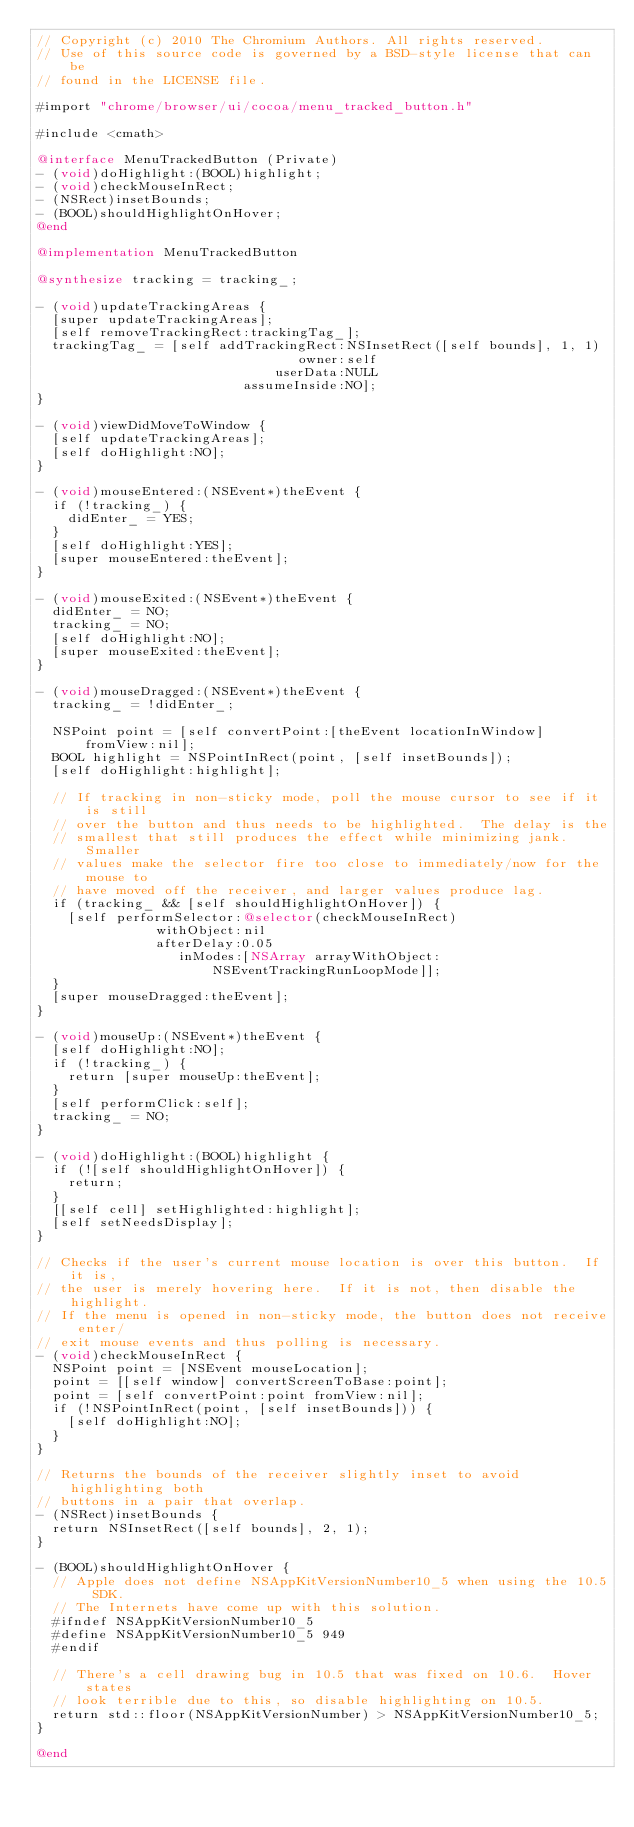<code> <loc_0><loc_0><loc_500><loc_500><_ObjectiveC_>// Copyright (c) 2010 The Chromium Authors. All rights reserved.
// Use of this source code is governed by a BSD-style license that can be
// found in the LICENSE file.

#import "chrome/browser/ui/cocoa/menu_tracked_button.h"

#include <cmath>

@interface MenuTrackedButton (Private)
- (void)doHighlight:(BOOL)highlight;
- (void)checkMouseInRect;
- (NSRect)insetBounds;
- (BOOL)shouldHighlightOnHover;
@end

@implementation MenuTrackedButton

@synthesize tracking = tracking_;

- (void)updateTrackingAreas {
  [super updateTrackingAreas];
  [self removeTrackingRect:trackingTag_];
  trackingTag_ = [self addTrackingRect:NSInsetRect([self bounds], 1, 1)
                                 owner:self
                              userData:NULL
                          assumeInside:NO];
}

- (void)viewDidMoveToWindow {
  [self updateTrackingAreas];
  [self doHighlight:NO];
}

- (void)mouseEntered:(NSEvent*)theEvent {
  if (!tracking_) {
    didEnter_ = YES;
  }
  [self doHighlight:YES];
  [super mouseEntered:theEvent];
}

- (void)mouseExited:(NSEvent*)theEvent {
  didEnter_ = NO;
  tracking_ = NO;
  [self doHighlight:NO];
  [super mouseExited:theEvent];
}

- (void)mouseDragged:(NSEvent*)theEvent {
  tracking_ = !didEnter_;

  NSPoint point = [self convertPoint:[theEvent locationInWindow] fromView:nil];
  BOOL highlight = NSPointInRect(point, [self insetBounds]);
  [self doHighlight:highlight];

  // If tracking in non-sticky mode, poll the mouse cursor to see if it is still
  // over the button and thus needs to be highlighted.  The delay is the
  // smallest that still produces the effect while minimizing jank. Smaller
  // values make the selector fire too close to immediately/now for the mouse to
  // have moved off the receiver, and larger values produce lag.
  if (tracking_ && [self shouldHighlightOnHover]) {
    [self performSelector:@selector(checkMouseInRect)
               withObject:nil
               afterDelay:0.05
                  inModes:[NSArray arrayWithObject:NSEventTrackingRunLoopMode]];
  }
  [super mouseDragged:theEvent];
}

- (void)mouseUp:(NSEvent*)theEvent {
  [self doHighlight:NO];
  if (!tracking_) {
    return [super mouseUp:theEvent];
  }
  [self performClick:self];
  tracking_ = NO;
}

- (void)doHighlight:(BOOL)highlight {
  if (![self shouldHighlightOnHover]) {
    return;
  }
  [[self cell] setHighlighted:highlight];
  [self setNeedsDisplay];
}

// Checks if the user's current mouse location is over this button.  If it is,
// the user is merely hovering here.  If it is not, then disable the highlight.
// If the menu is opened in non-sticky mode, the button does not receive enter/
// exit mouse events and thus polling is necessary.
- (void)checkMouseInRect {
  NSPoint point = [NSEvent mouseLocation];
  point = [[self window] convertScreenToBase:point];
  point = [self convertPoint:point fromView:nil];
  if (!NSPointInRect(point, [self insetBounds])) {
    [self doHighlight:NO];
  }
}

// Returns the bounds of the receiver slightly inset to avoid highlighting both
// buttons in a pair that overlap.
- (NSRect)insetBounds {
  return NSInsetRect([self bounds], 2, 1);
}

- (BOOL)shouldHighlightOnHover {
  // Apple does not define NSAppKitVersionNumber10_5 when using the 10.5 SDK.
  // The Internets have come up with this solution.
  #ifndef NSAppKitVersionNumber10_5
  #define NSAppKitVersionNumber10_5 949
  #endif

  // There's a cell drawing bug in 10.5 that was fixed on 10.6.  Hover states
  // look terrible due to this, so disable highlighting on 10.5.
  return std::floor(NSAppKitVersionNumber) > NSAppKitVersionNumber10_5;
}

@end
</code> 